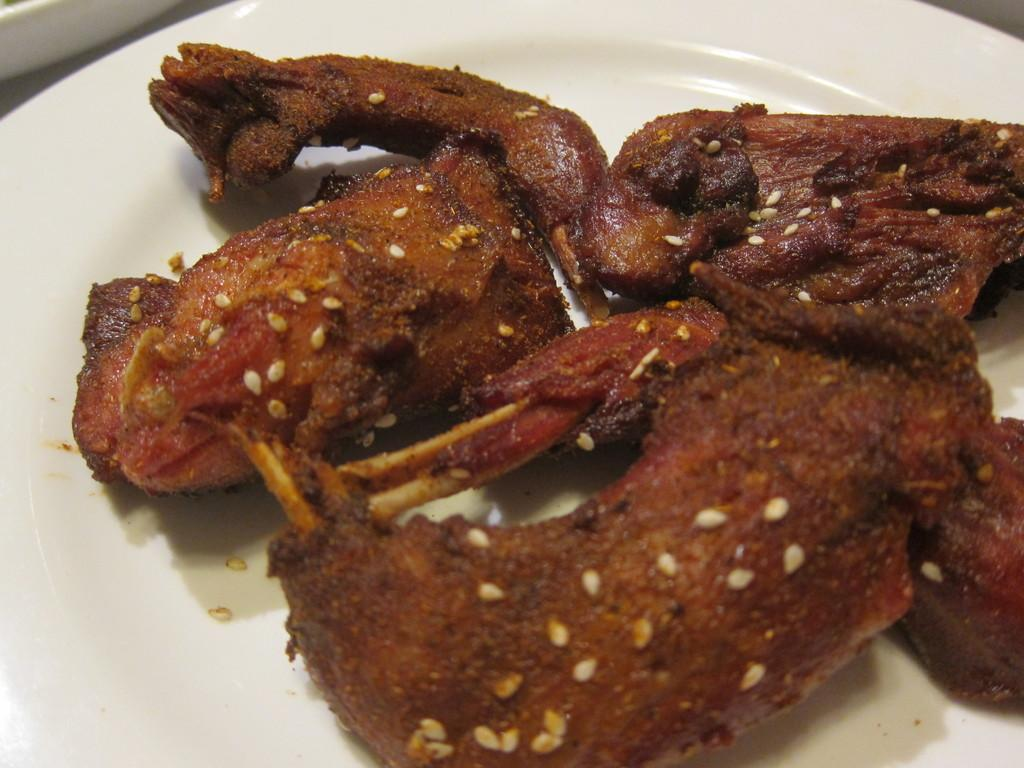What is on the plate in the image? There are food items on a plate in the image. What color is the plate? The plate is white. How does the stranger interact with the art in the image? There is no stranger or art present in the image; it only features a plate with food items and a white plate. 